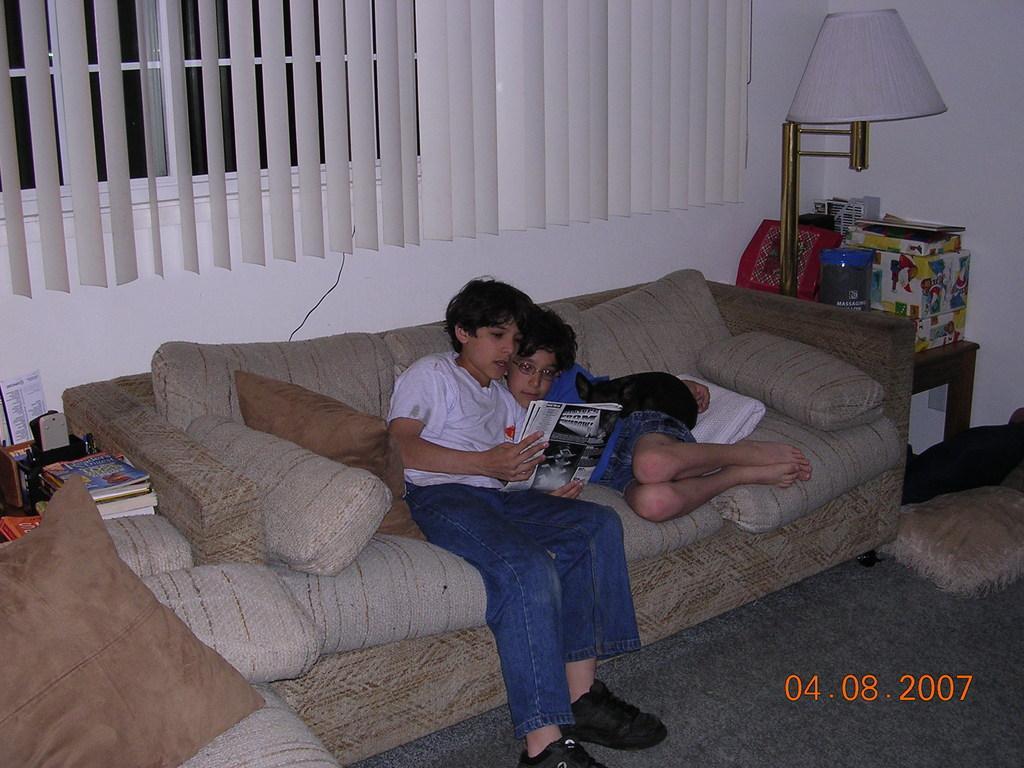Please provide a concise description of this image. In this image we can see two people sitting on the sofa. There are cushions placed on the sofa. The boy sitting on the left is holding a book. There are stands and we can see a lamp, cardboard boxes, books, papers, holders and some objects placed on the stand. In the background there is a window and we can see blinds. There is a wall. 